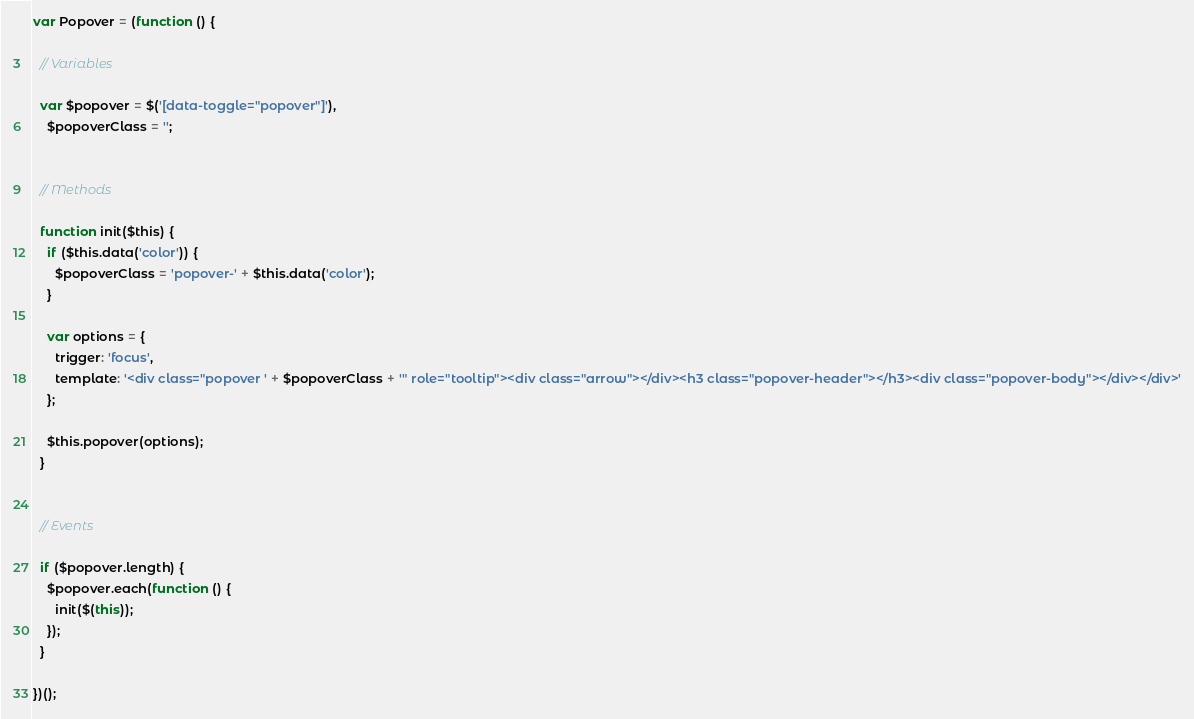Convert code to text. <code><loc_0><loc_0><loc_500><loc_500><_JavaScript_>
var Popover = (function () {

  // Variables

  var $popover = $('[data-toggle="popover"]'),
    $popoverClass = '';


  // Methods

  function init($this) {
    if ($this.data('color')) {
      $popoverClass = 'popover-' + $this.data('color');
    }

    var options = {
      trigger: 'focus',
      template: '<div class="popover ' + $popoverClass + '" role="tooltip"><div class="arrow"></div><h3 class="popover-header"></h3><div class="popover-body"></div></div>'
    };

    $this.popover(options);
  }


  // Events

  if ($popover.length) {
    $popover.each(function () {
      init($(this));
    });
  }

})();
</code> 